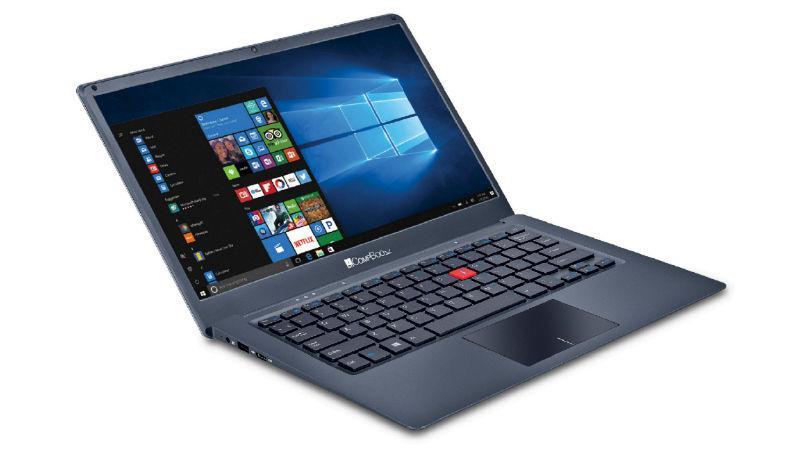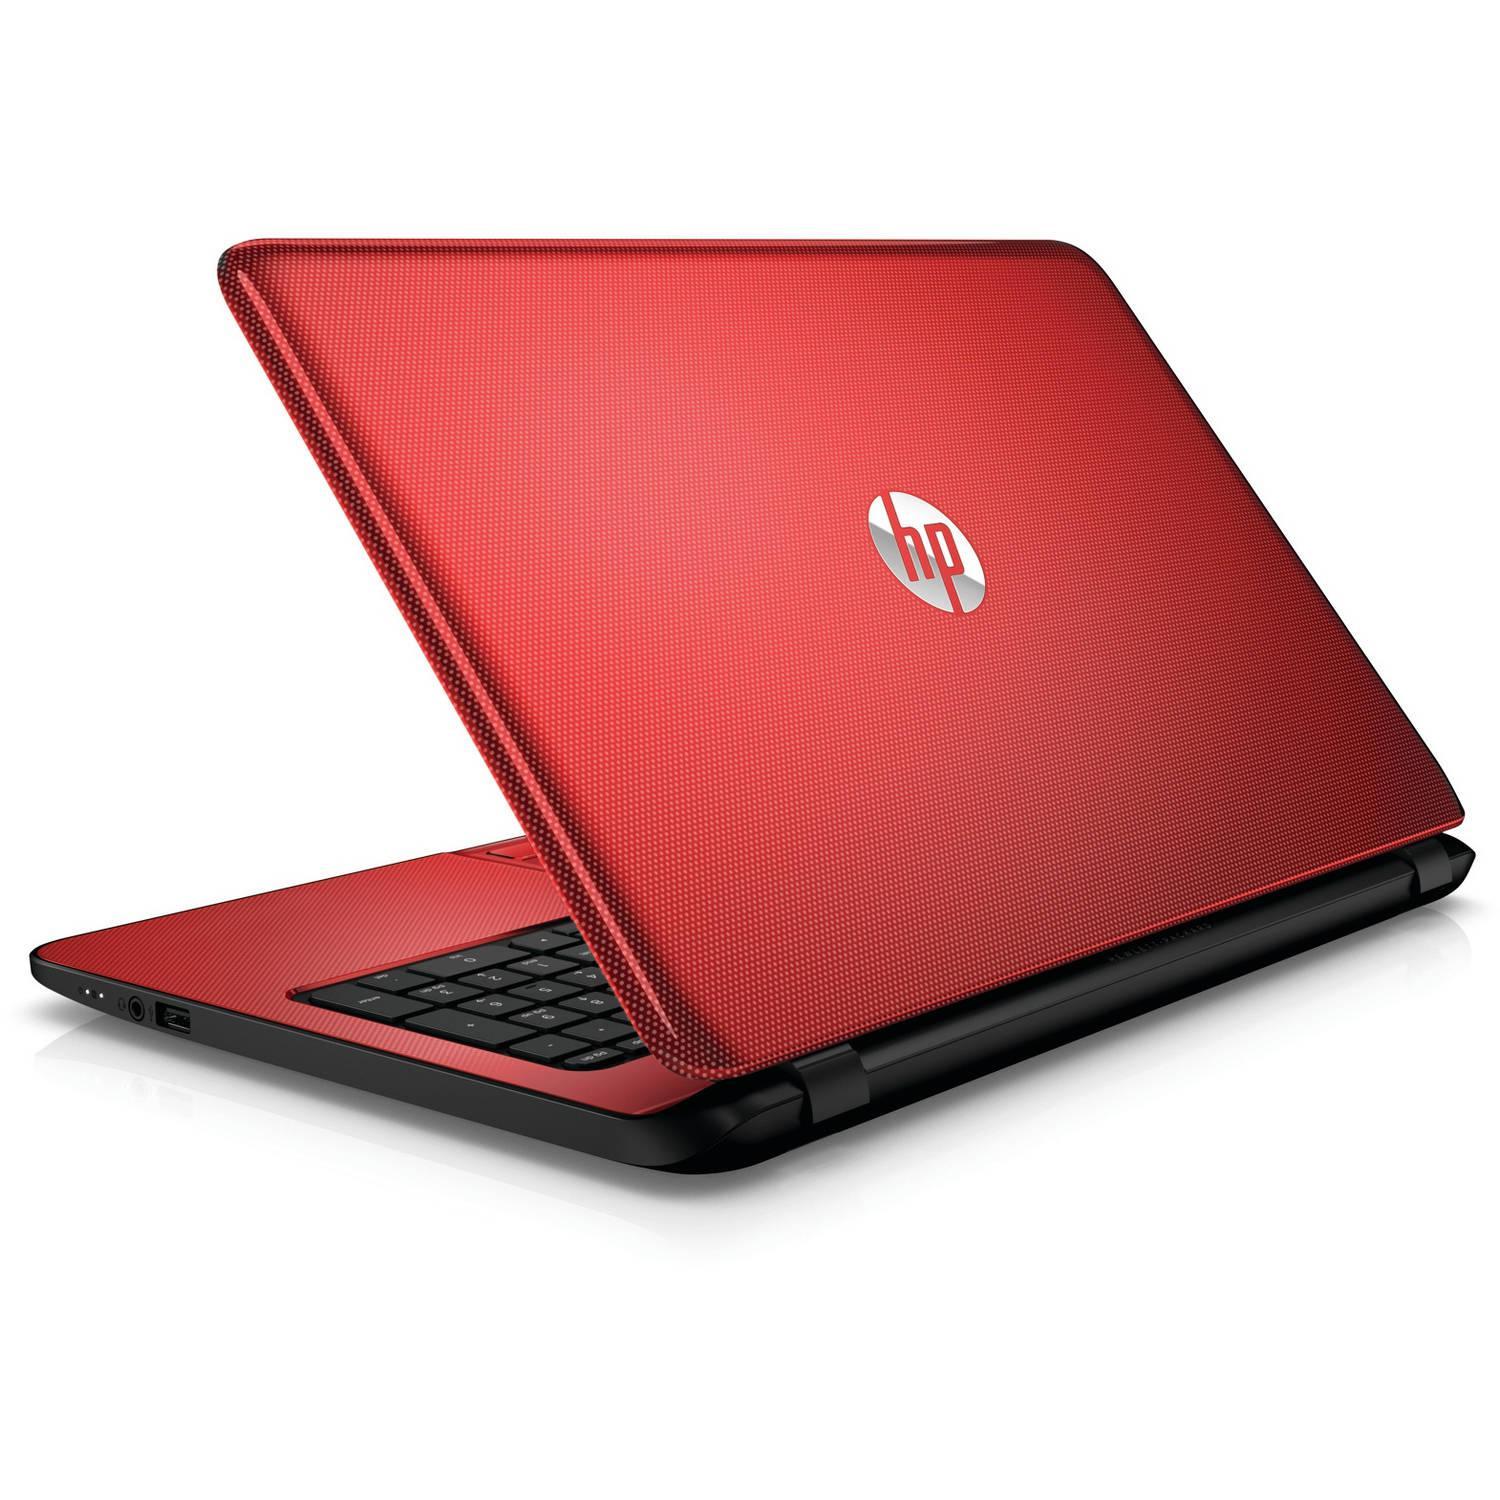The first image is the image on the left, the second image is the image on the right. For the images shown, is this caption "The full back of the red laptop is being shown." true? Answer yes or no. Yes. The first image is the image on the left, the second image is the image on the right. Evaluate the accuracy of this statement regarding the images: "One of the laptops is turned so the screen is visible, and the other is turned so that the screen is not visible.". Is it true? Answer yes or no. Yes. 